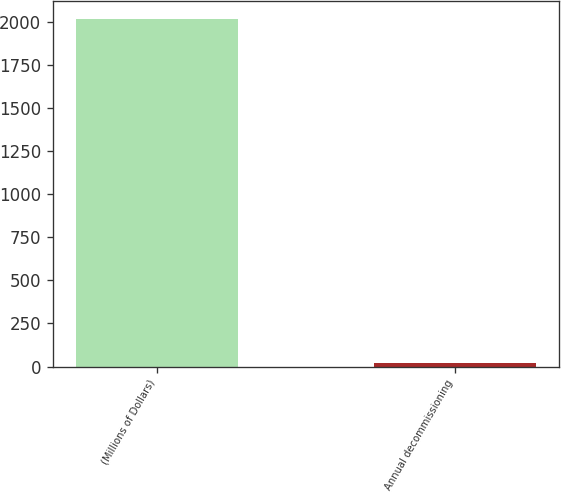Convert chart. <chart><loc_0><loc_0><loc_500><loc_500><bar_chart><fcel>(Millions of Dollars)<fcel>Annual decommissioning<nl><fcel>2018<fcel>20<nl></chart> 